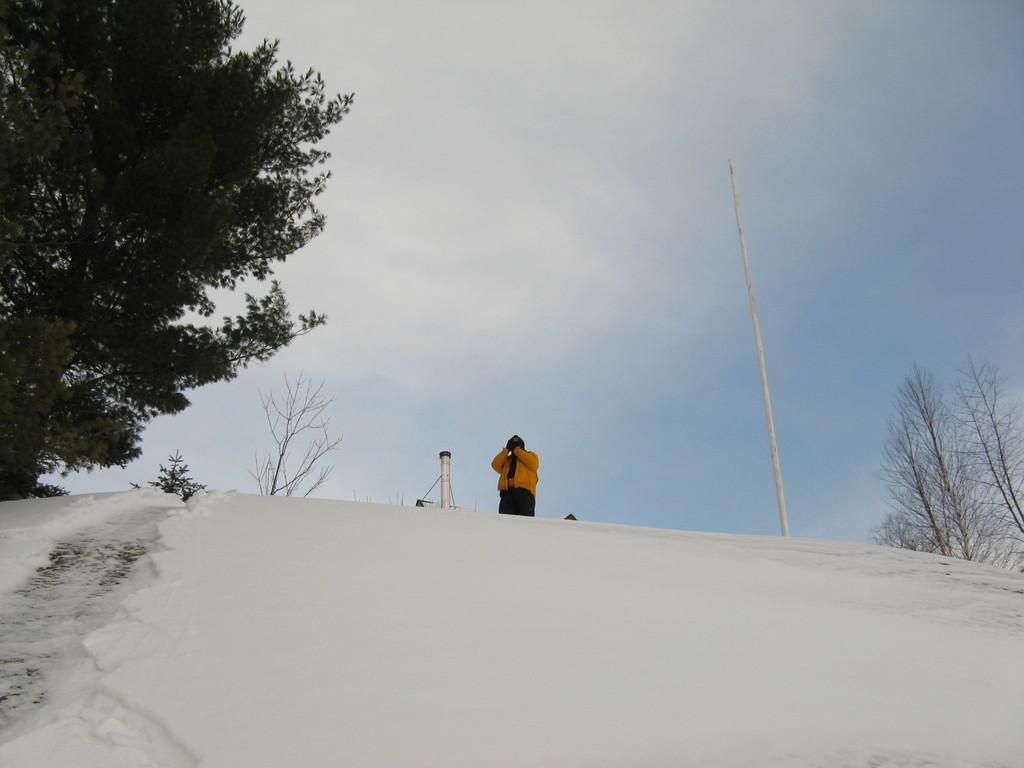Can you describe this image briefly? In this picture I can observe a person standing, wearing yellow color jacket. There is snow on the land. I can observe white color pole on the right side. On the left side there is a tree and I can observe some dried trees on the right side. In the background there is a sky with some clouds. 